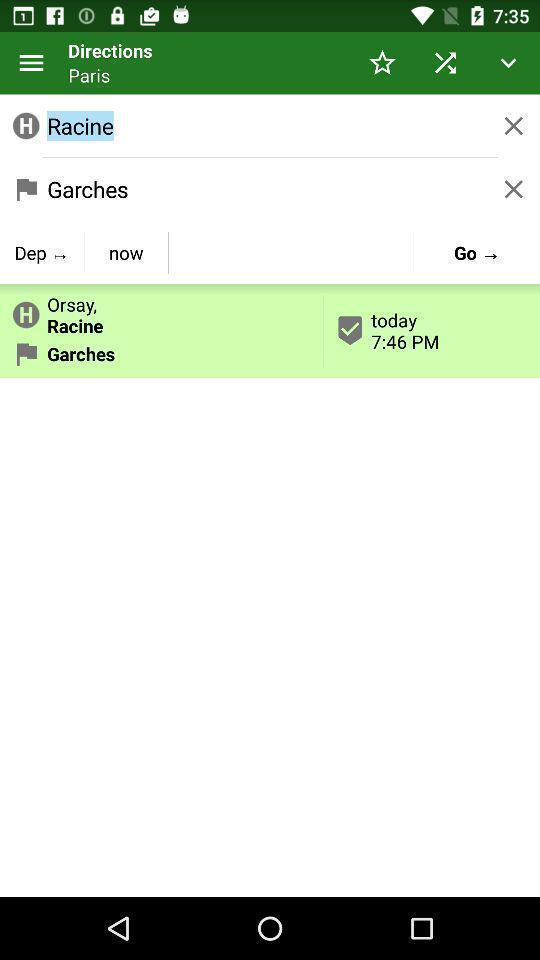Provide a description of this screenshot. Page displays directions in app. 